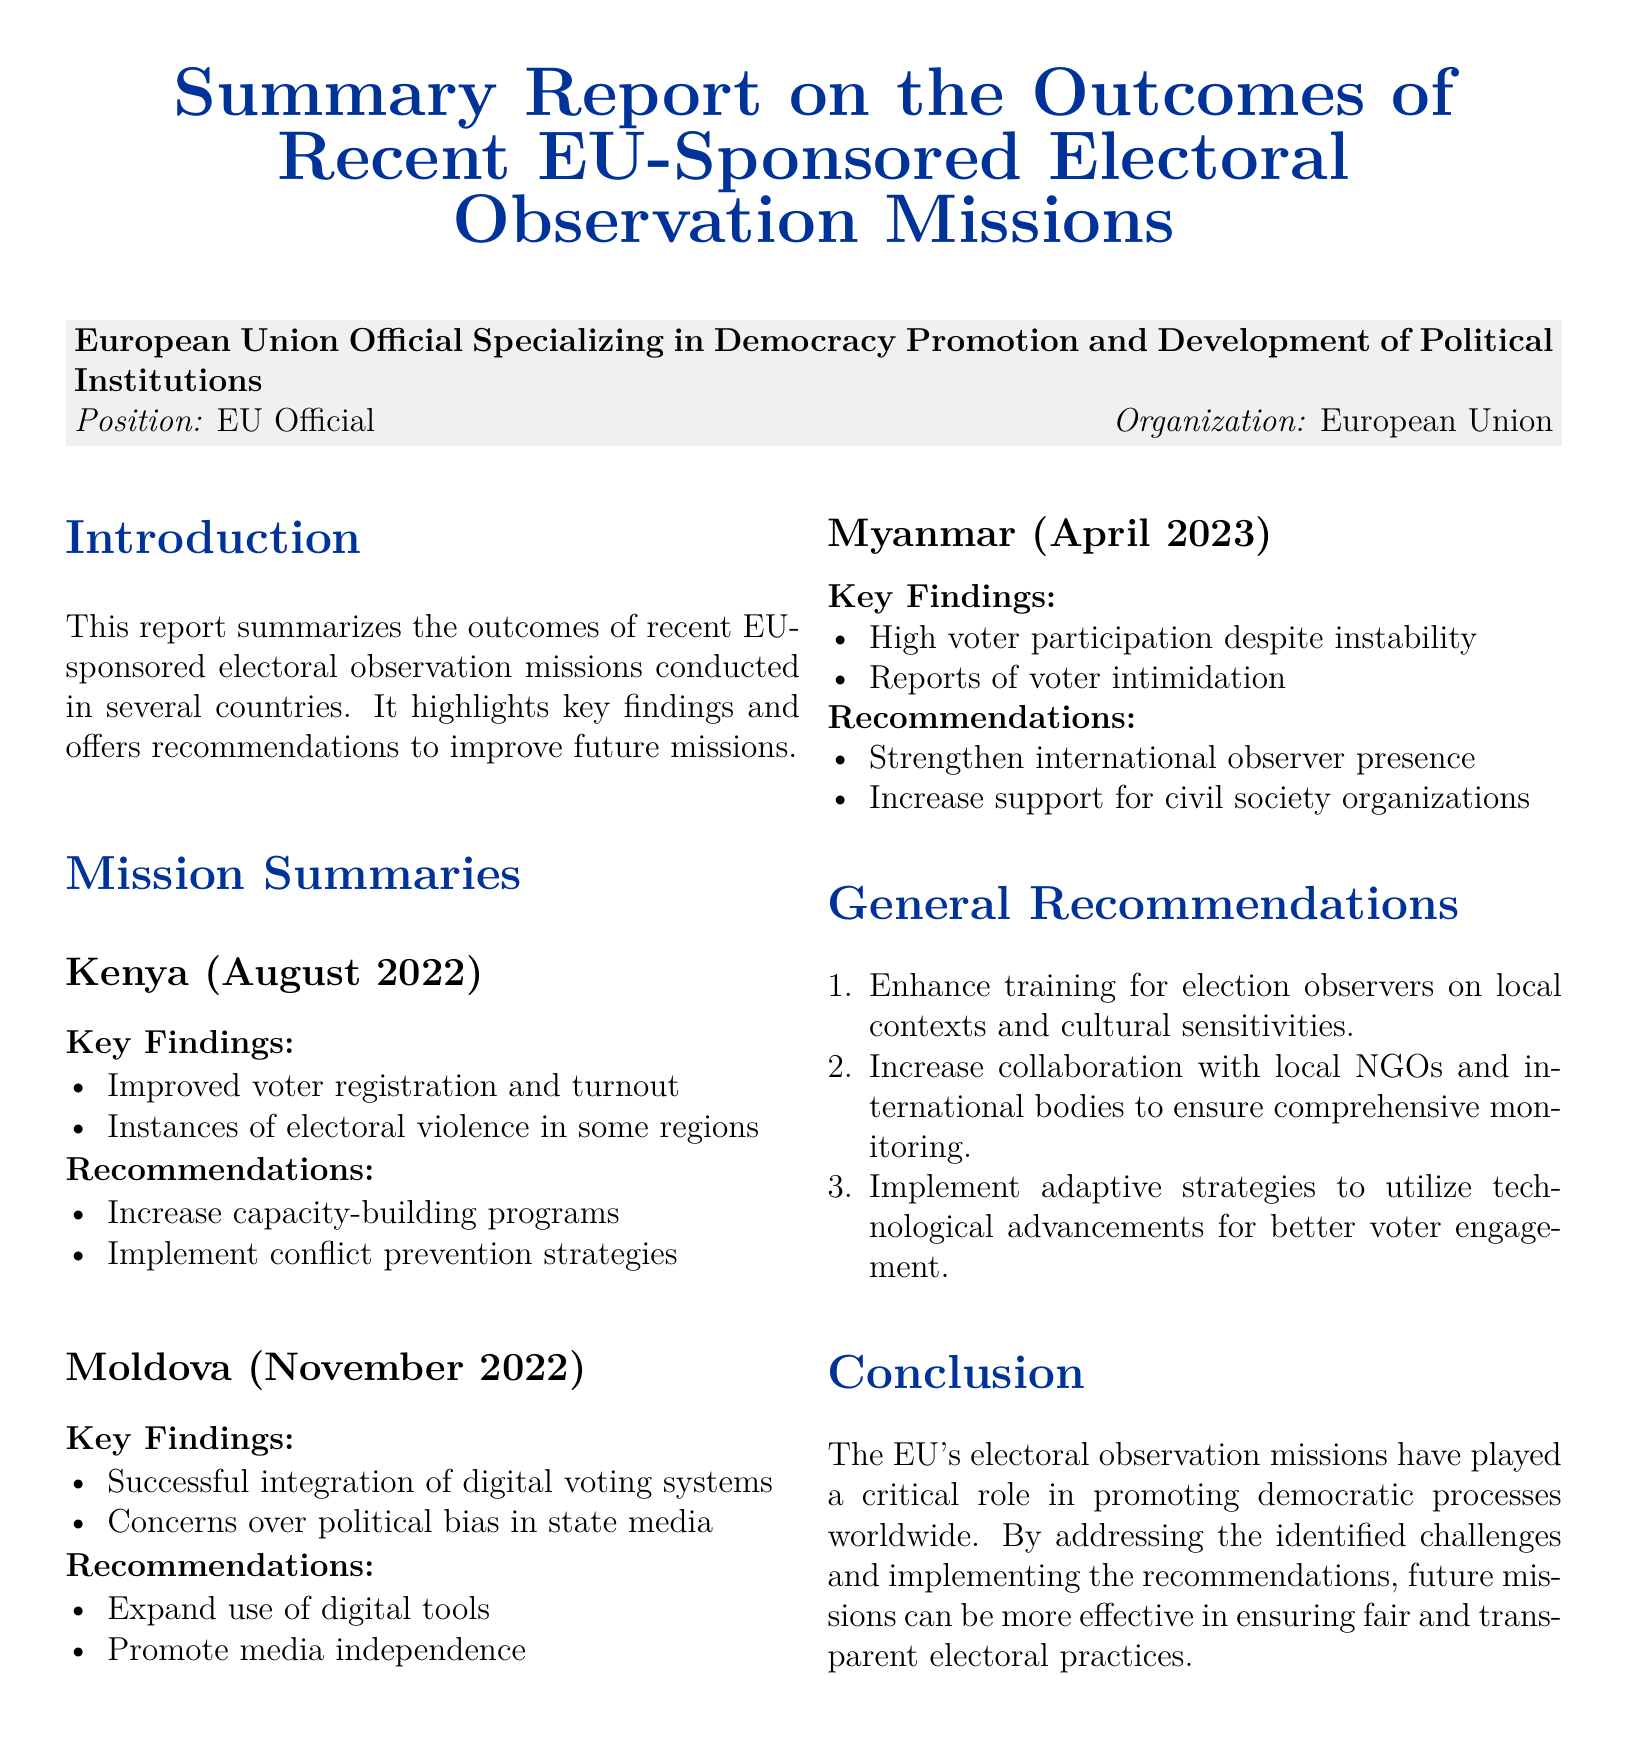what country had electoral violence in August 2022? The document mentions instances of electoral violence in regions of Kenya during the August 2022 mission.
Answer: Kenya what was a key finding from Moldova's mission in November 2022? The report highlights the successful integration of digital voting systems as a key finding during the Moldova mission.
Answer: Successful integration of digital voting systems what is one recommendation for Myanmar based on the April 2023 mission? One recommendation provided for Myanmar after the April 2023 mission is to strengthen international observer presence.
Answer: Strengthen international observer presence how many general recommendations are provided in the report? The document lists three general recommendations for improving future electoral observation missions.
Answer: 3 what is one concern raised in Moldova regarding media? The report raises concerns over political bias in state media during the Moldova mission.
Answer: Political bias in state media which aspect is recommended to enhance election observers' effectiveness? The report suggests enhancing training for election observers on local contexts and cultural sensitivities.
Answer: Training on local contexts what was the voter participation status in Myanmar? The document notes high voter participation despite the instability in Myanmar during the April 2023 mission.
Answer: High voter participation what is the role of the EU's electoral observation missions as stated in the conclusion? The conclusion emphasizes that the EU's electoral observation missions play a critical role in promoting democratic processes worldwide.
Answer: Promoting democratic processes 